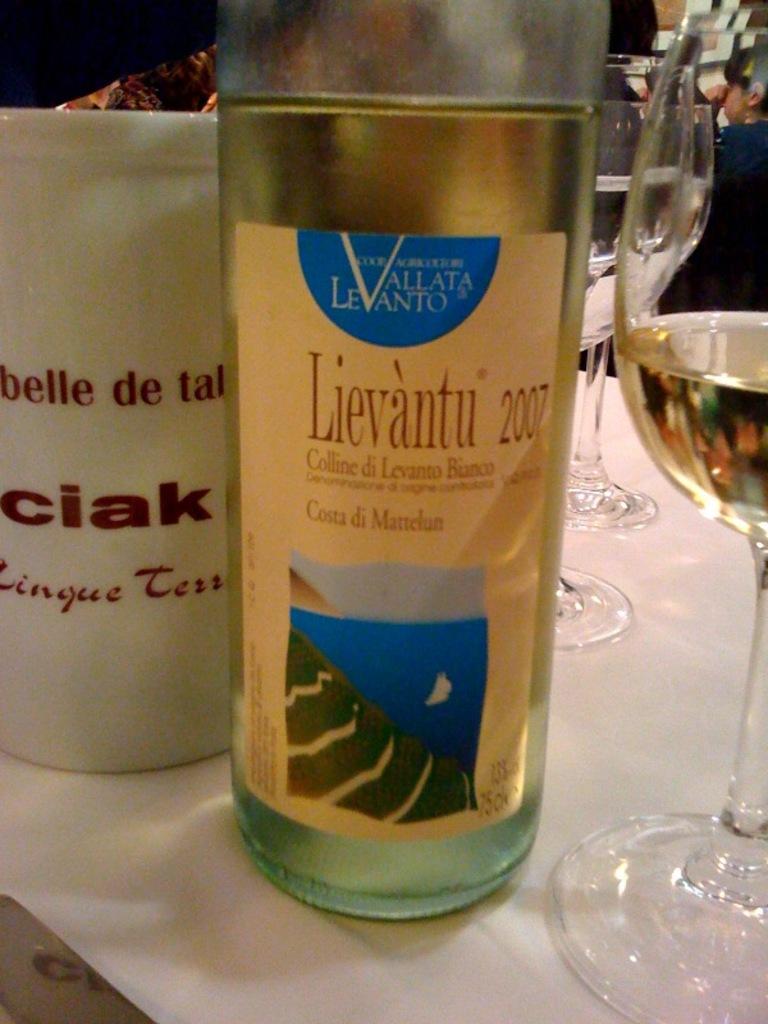Was lievantu 2007 really produced in 2007?
Your response must be concise. Yes. What agriculture cooperative does the bottle belong to?
Your response must be concise. Unanswerable. 